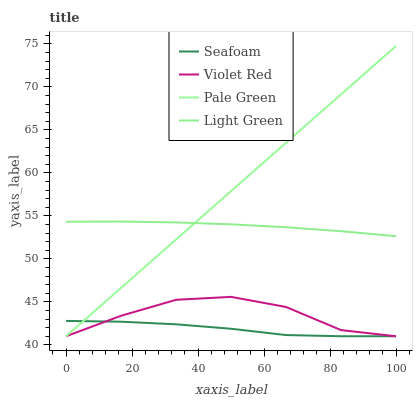Does Seafoam have the minimum area under the curve?
Answer yes or no. Yes. Does Pale Green have the maximum area under the curve?
Answer yes or no. Yes. Does Pale Green have the minimum area under the curve?
Answer yes or no. No. Does Seafoam have the maximum area under the curve?
Answer yes or no. No. Is Pale Green the smoothest?
Answer yes or no. Yes. Is Violet Red the roughest?
Answer yes or no. Yes. Is Seafoam the smoothest?
Answer yes or no. No. Is Seafoam the roughest?
Answer yes or no. No. Does Violet Red have the lowest value?
Answer yes or no. Yes. Does Light Green have the lowest value?
Answer yes or no. No. Does Pale Green have the highest value?
Answer yes or no. Yes. Does Seafoam have the highest value?
Answer yes or no. No. Is Violet Red less than Light Green?
Answer yes or no. Yes. Is Light Green greater than Violet Red?
Answer yes or no. Yes. Does Light Green intersect Pale Green?
Answer yes or no. Yes. Is Light Green less than Pale Green?
Answer yes or no. No. Is Light Green greater than Pale Green?
Answer yes or no. No. Does Violet Red intersect Light Green?
Answer yes or no. No. 